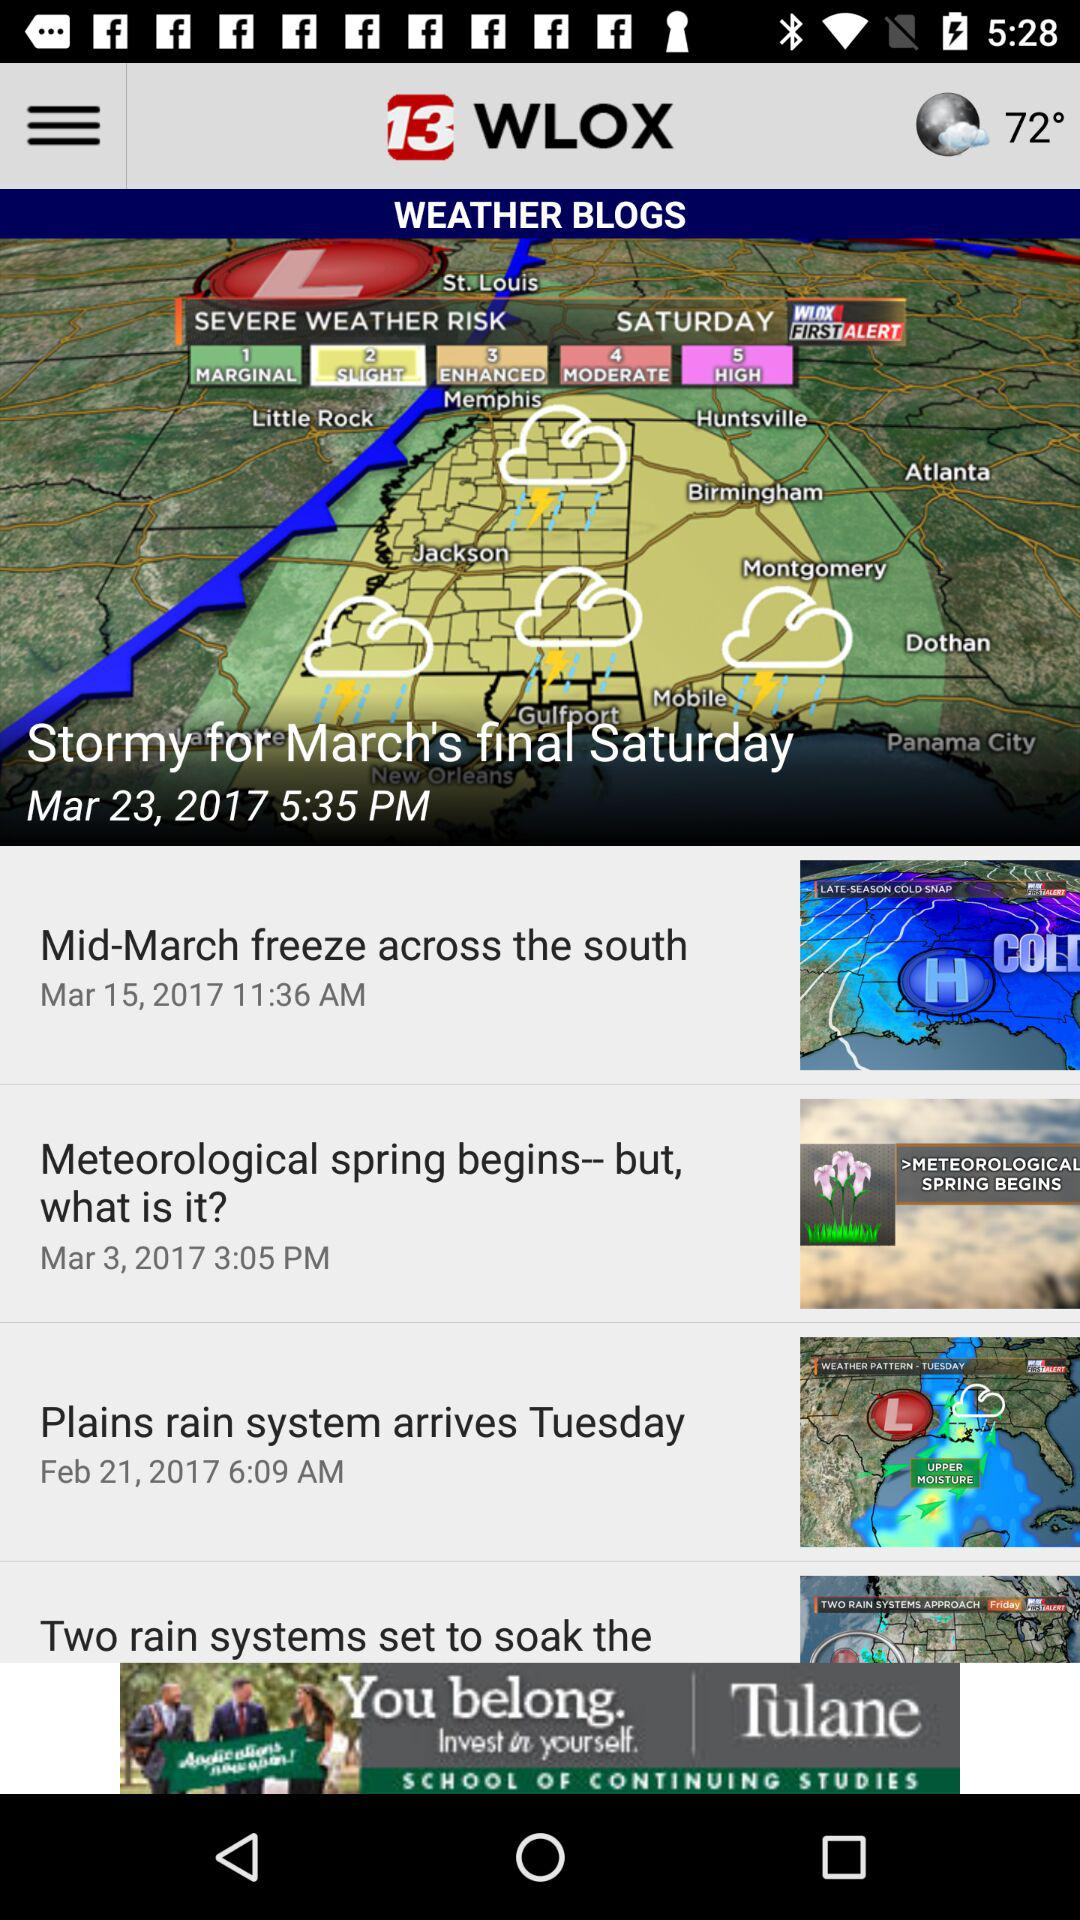How many days are mentioned in the weather blog posts?
Answer the question using a single word or phrase. 4 